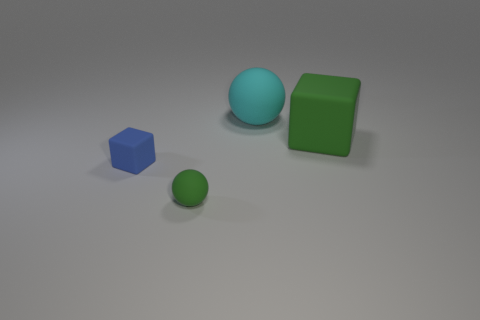Add 3 large cyan cubes. How many objects exist? 7 Add 1 cyan balls. How many cyan balls are left? 2 Add 3 blue matte blocks. How many blue matte blocks exist? 4 Subtract 0 red cubes. How many objects are left? 4 Subtract all big brown spheres. Subtract all large green rubber blocks. How many objects are left? 3 